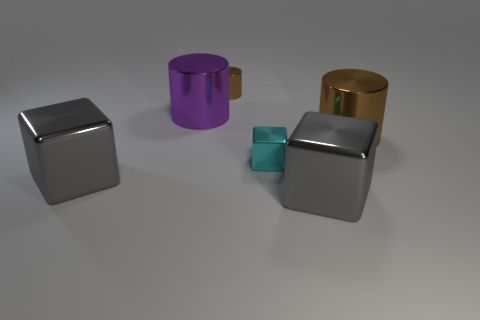Is there any other thing of the same color as the small metal cylinder?
Provide a succinct answer. Yes. What is the big brown object made of?
Your response must be concise. Metal. There is a tiny shiny cylinder; does it have the same color as the large metallic cylinder to the right of the big purple metallic cylinder?
Make the answer very short. Yes. What number of cyan shiny blocks are behind the cyan metal block?
Your response must be concise. 0. Is the number of large gray metallic cubes that are on the left side of the tiny cyan metallic cube less than the number of small things?
Your response must be concise. Yes. The tiny cube has what color?
Provide a succinct answer. Cyan. Does the metallic cylinder that is right of the tiny cyan block have the same color as the small shiny cylinder?
Ensure brevity in your answer.  Yes. What is the color of the tiny shiny thing that is the same shape as the large purple thing?
Keep it short and to the point. Brown. What number of large things are gray cubes or shiny cubes?
Make the answer very short. 2. There is a brown cylinder that is left of the small cyan metallic object; how big is it?
Provide a succinct answer. Small. 